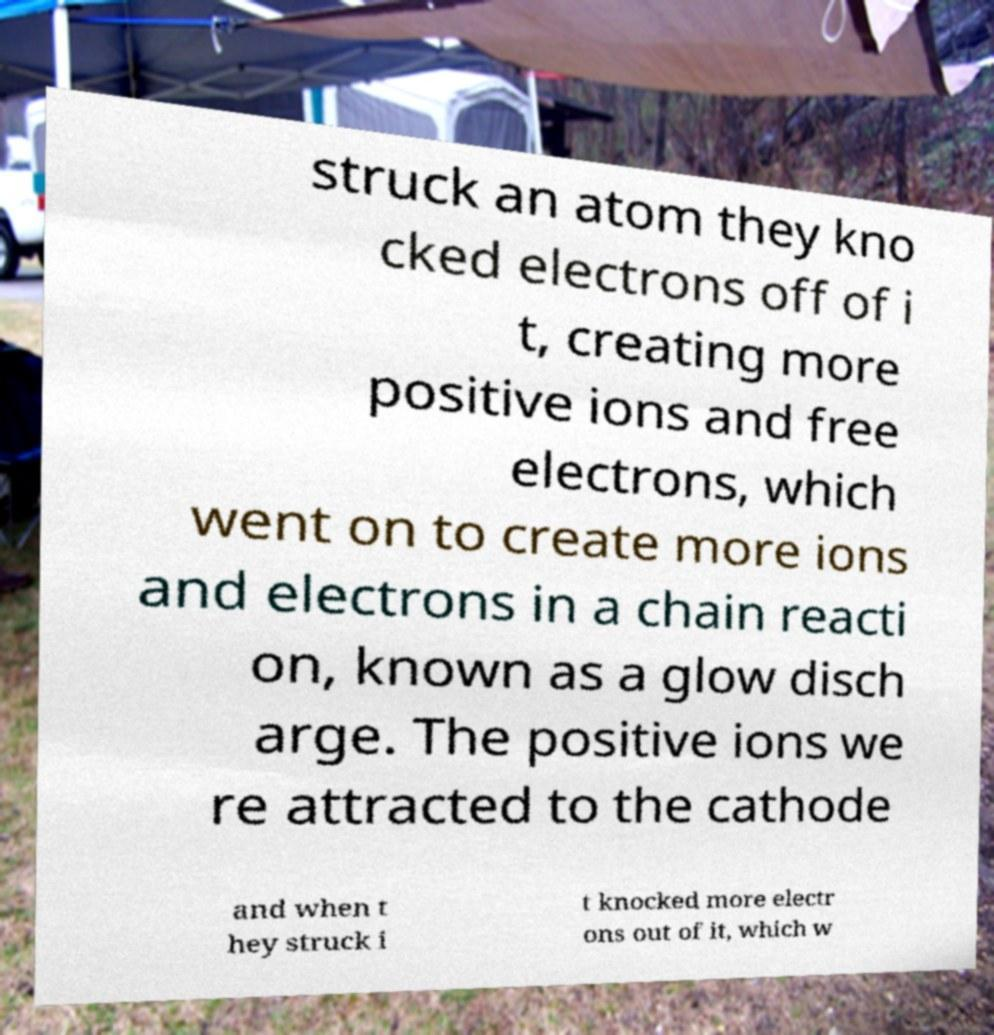Could you extract and type out the text from this image? struck an atom they kno cked electrons off of i t, creating more positive ions and free electrons, which went on to create more ions and electrons in a chain reacti on, known as a glow disch arge. The positive ions we re attracted to the cathode and when t hey struck i t knocked more electr ons out of it, which w 